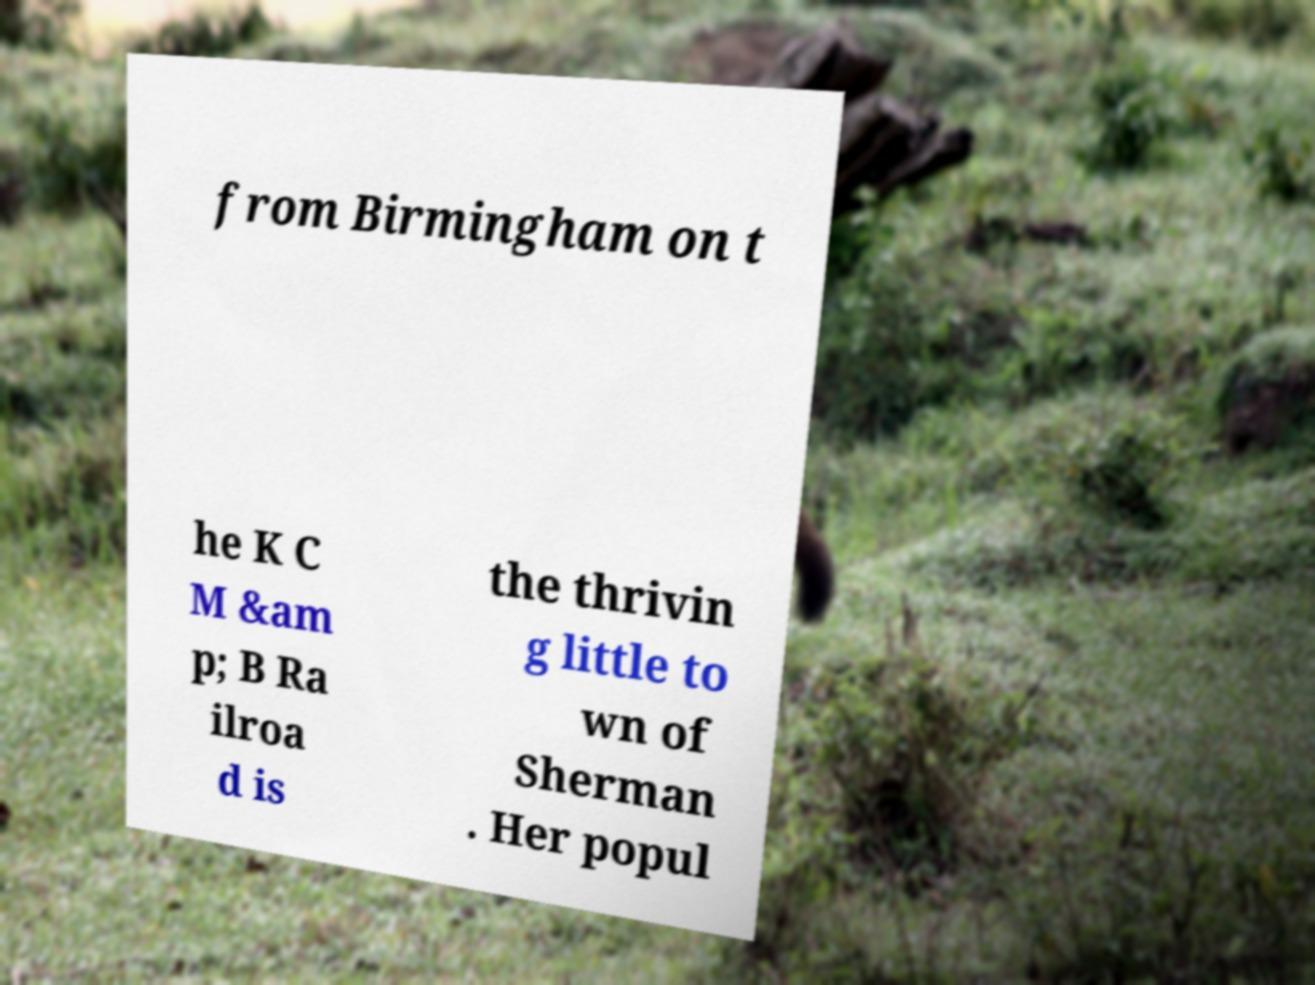Please identify and transcribe the text found in this image. from Birmingham on t he K C M &am p; B Ra ilroa d is the thrivin g little to wn of Sherman . Her popul 